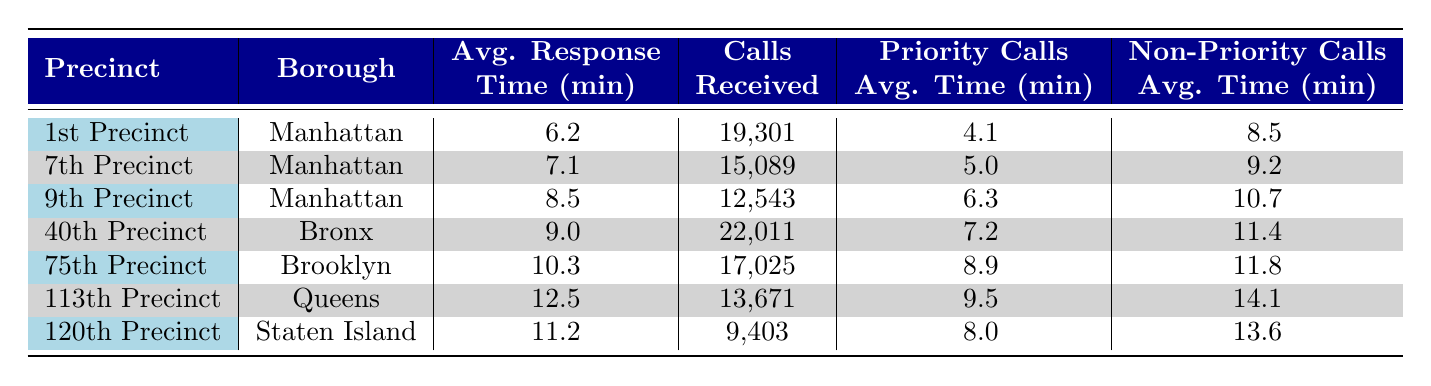What is the average response time for the 1st Precinct? The average response time for the 1st Precinct is listed in the table under the "Avg. Response Time (min)" column. It shows a value of 6.2 minutes.
Answer: 6.2 minutes Which precinct received the highest number of calls? Looking at the "Calls Received" column, the 40th Precinct has the highest number with 22,011 calls.
Answer: 40th Precinct Is the priority call average time for the 75th Precinct more than 9 minutes? We can find the priority call average time for the 75th Precinct in the table, which is 8.9 minutes. Since 8.9 is less than 9, the answer is no.
Answer: No What is the difference in average response time between the 1st and 113th Precincts? The average response time for the 1st Precinct is 6.2 minutes, while for the 113th Precinct it is 12.5 minutes. To find the difference, we subtract: 12.5 - 6.2 = 6.3 minutes.
Answer: 6.3 minutes Which borough has the lowest average response time for its precinct listed in the table? By comparing the average response times across all precincts listed, the 1st Precinct in Manhattan has the lowest average at 6.2 minutes.
Answer: Manhattan How many calls were received in total for all Manhattan precincts combined? The table lists the calls received for Manhattan precincts: 1st (19,301) + 7th (15,089) + 9th (12,543). Adding these figures: 19,301 + 15,089 + 12,543 = 46,933 total calls.
Answer: 46,933 calls Does the non-priority call average time for the 120th Precinct exceed 12 minutes? The non-priority call average time for the 120th Precinct is 13.6 minutes, which is indeed more than 12 minutes. Therefore, the answer is yes.
Answer: Yes What is the average of priority call average times for all precincts listed? To find the average of priority call times, we first sum up the priority average times: 4.1 + 5.0 + 6.3 + 7.2 + 8.9 + 9.5 + 8.0 = 49.0. We then divide by the number of precincts, which is 7: 49.0 / 7 = 7.0 minutes.
Answer: 7.0 minutes 